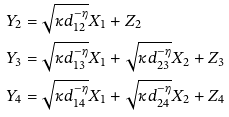<formula> <loc_0><loc_0><loc_500><loc_500>Y _ { 2 } & = \sqrt { \kappa d _ { 1 2 } ^ { - \eta } } X _ { 1 } + Z _ { 2 } \\ Y _ { 3 } & = \sqrt { \kappa d _ { 1 3 } ^ { - \eta } } X _ { 1 } + \sqrt { \kappa d _ { 2 3 } ^ { - \eta } } X _ { 2 } + Z _ { 3 } \\ Y _ { 4 } & = \sqrt { \kappa d _ { 1 4 } ^ { - \eta } } X _ { 1 } + \sqrt { \kappa d _ { 2 4 } ^ { - \eta } } X _ { 2 } + Z _ { 4 } \\</formula> 